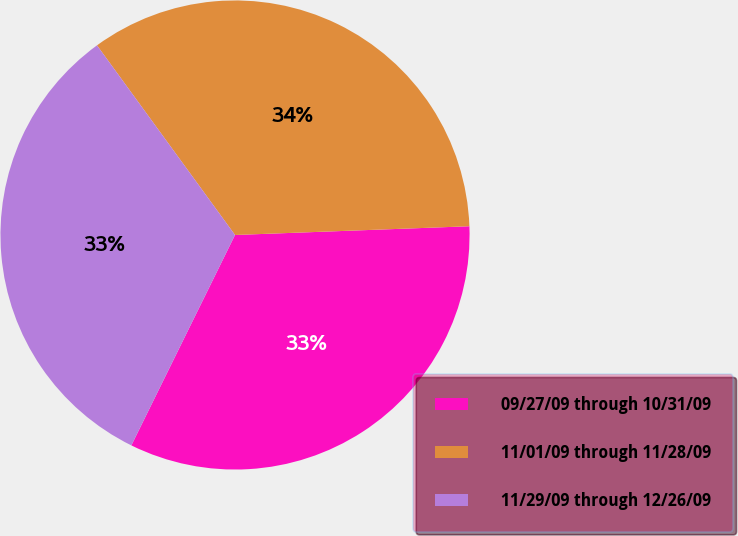Convert chart. <chart><loc_0><loc_0><loc_500><loc_500><pie_chart><fcel>09/27/09 through 10/31/09<fcel>11/01/09 through 11/28/09<fcel>11/29/09 through 12/26/09<nl><fcel>32.88%<fcel>34.42%<fcel>32.7%<nl></chart> 